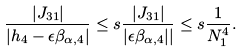Convert formula to latex. <formula><loc_0><loc_0><loc_500><loc_500>\frac { | J _ { 3 1 } | } { | h _ { 4 } - \epsilon \beta _ { \alpha , 4 } | } \leq s \frac { | J _ { 3 1 } | } { | \epsilon \beta _ { \alpha , 4 } | | } \leq s \frac { 1 } { N _ { 1 } ^ { 4 } } .</formula> 